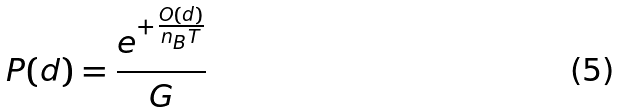Convert formula to latex. <formula><loc_0><loc_0><loc_500><loc_500>P ( d ) = \frac { e ^ { + \frac { O ( d ) } { n _ { B } T } } } { G }</formula> 